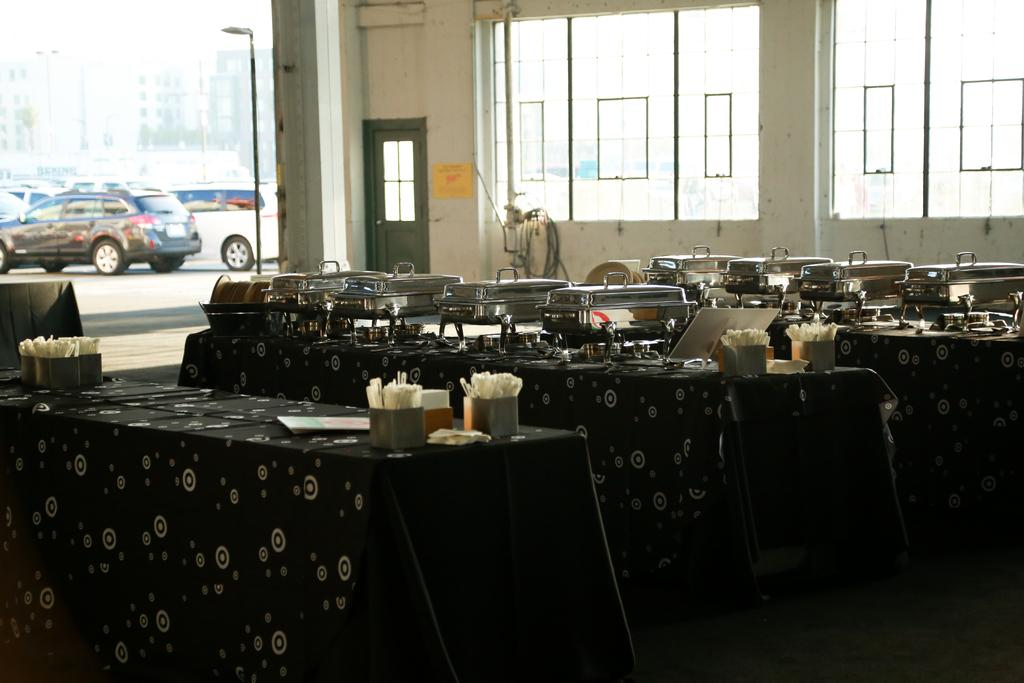What is placed on the table in the image? There are food buffets on a table. How is the table decorated or covered? The table is covered with a bed sheet cover. Can you describe the parking situation in the image? There are cars parked in a parking space. What type of flag is being waved by the carpenter in the image? There is no carpenter or flag present in the image. How many ducks are visible in the image? There are no ducks present in the image. 